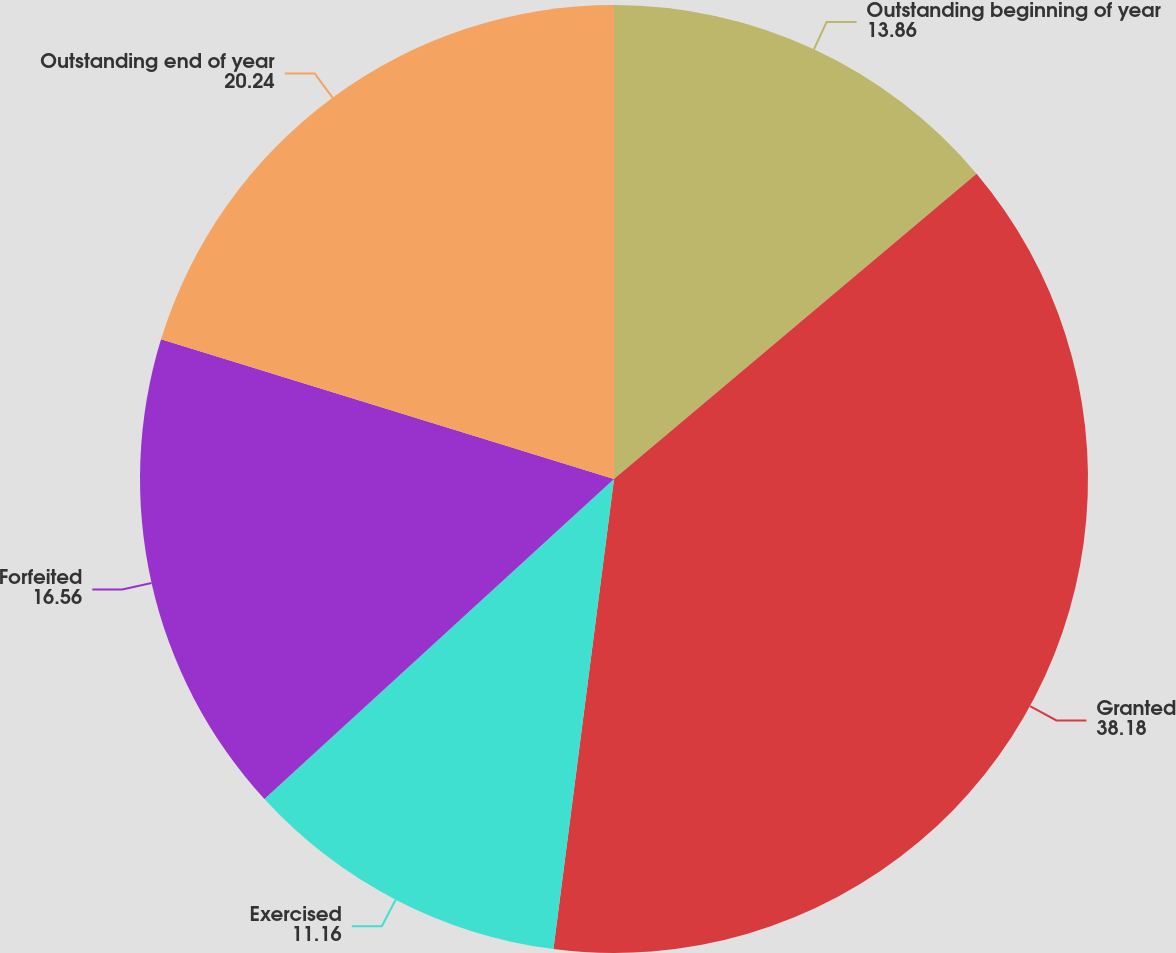Convert chart. <chart><loc_0><loc_0><loc_500><loc_500><pie_chart><fcel>Outstanding beginning of year<fcel>Granted<fcel>Exercised<fcel>Forfeited<fcel>Outstanding end of year<nl><fcel>13.86%<fcel>38.18%<fcel>11.16%<fcel>16.56%<fcel>20.24%<nl></chart> 